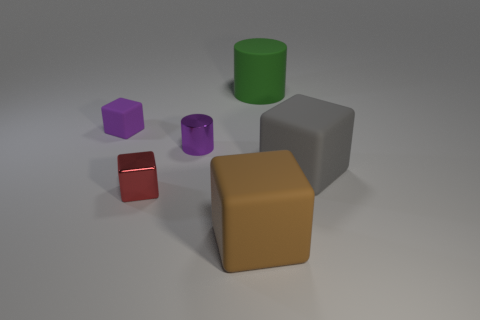Add 1 matte cylinders. How many objects exist? 7 Subtract all blocks. How many objects are left? 2 Subtract 0 green balls. How many objects are left? 6 Subtract all large yellow blocks. Subtract all gray things. How many objects are left? 5 Add 2 small purple things. How many small purple things are left? 4 Add 4 large yellow metallic objects. How many large yellow metallic objects exist? 4 